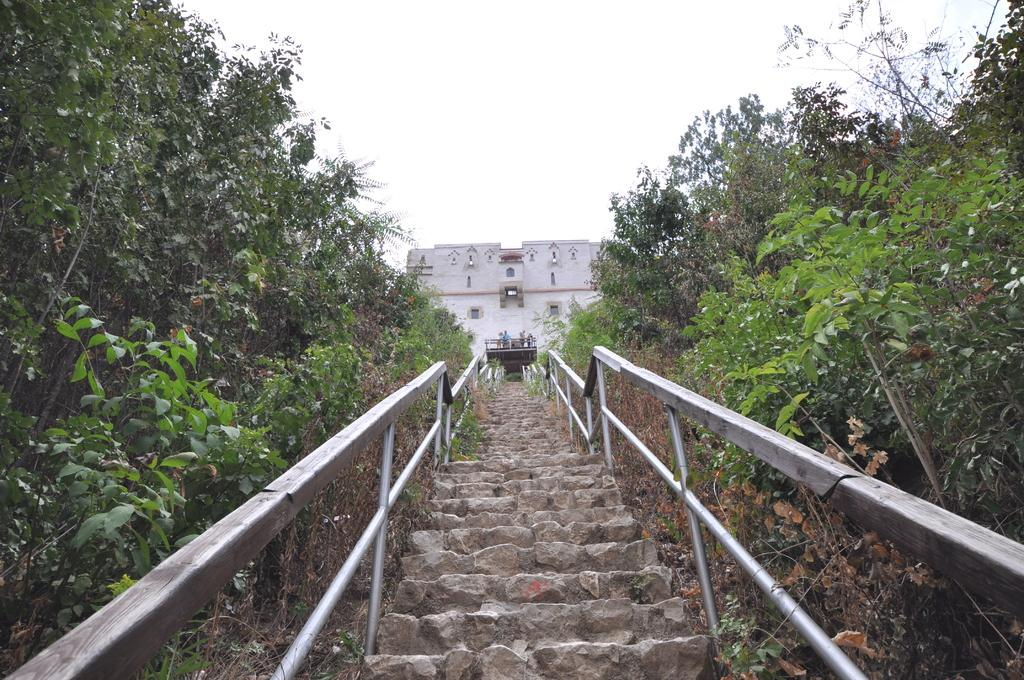What is located in the center of the image? There are stairs in the center of the image. What type of structure can be seen in the image? There is a building in the image. What natural elements are present in the image? There are many trees in the image. What is visible at the top of the image? The sky is visible at the top of the image. Can you tell me how many chickens are on the stairs in the image? There are no chickens present in the image; it features stairs, a building, trees, and the sky. 